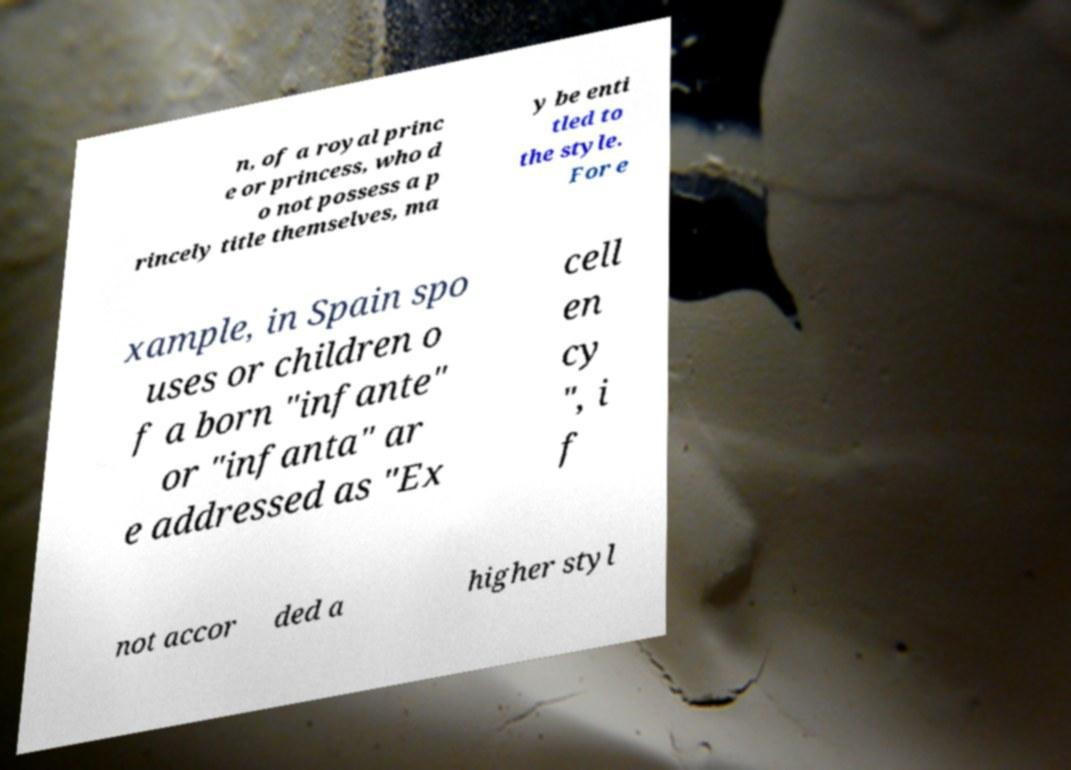Could you extract and type out the text from this image? n, of a royal princ e or princess, who d o not possess a p rincely title themselves, ma y be enti tled to the style. For e xample, in Spain spo uses or children o f a born "infante" or "infanta" ar e addressed as "Ex cell en cy ", i f not accor ded a higher styl 